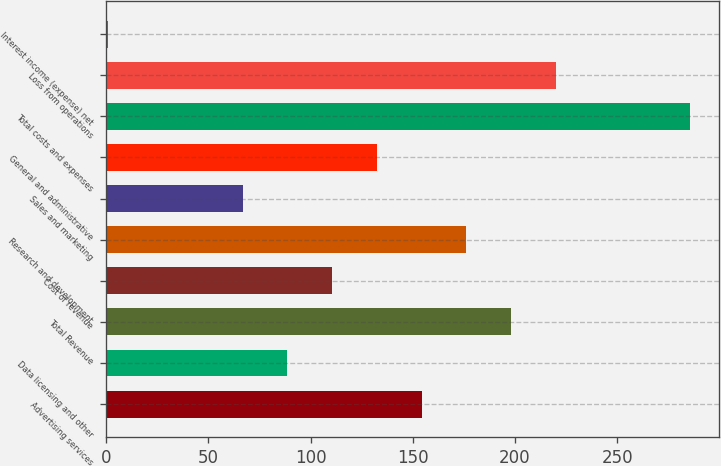Convert chart to OTSL. <chart><loc_0><loc_0><loc_500><loc_500><bar_chart><fcel>Advertising services<fcel>Data licensing and other<fcel>Total Revenue<fcel>Cost of revenue<fcel>Research and development<fcel>Sales and marketing<fcel>General and administrative<fcel>Total costs and expenses<fcel>Loss from operations<fcel>Interest income (expense) net<nl><fcel>154.3<fcel>88.6<fcel>198.1<fcel>110.5<fcel>176.2<fcel>66.7<fcel>132.4<fcel>285.7<fcel>220<fcel>1<nl></chart> 